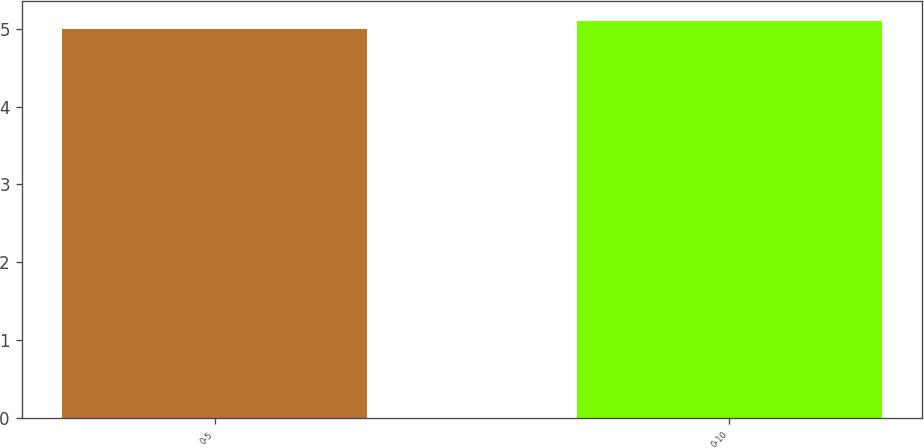<chart> <loc_0><loc_0><loc_500><loc_500><bar_chart><fcel>0-5<fcel>0-10<nl><fcel>5<fcel>5.1<nl></chart> 